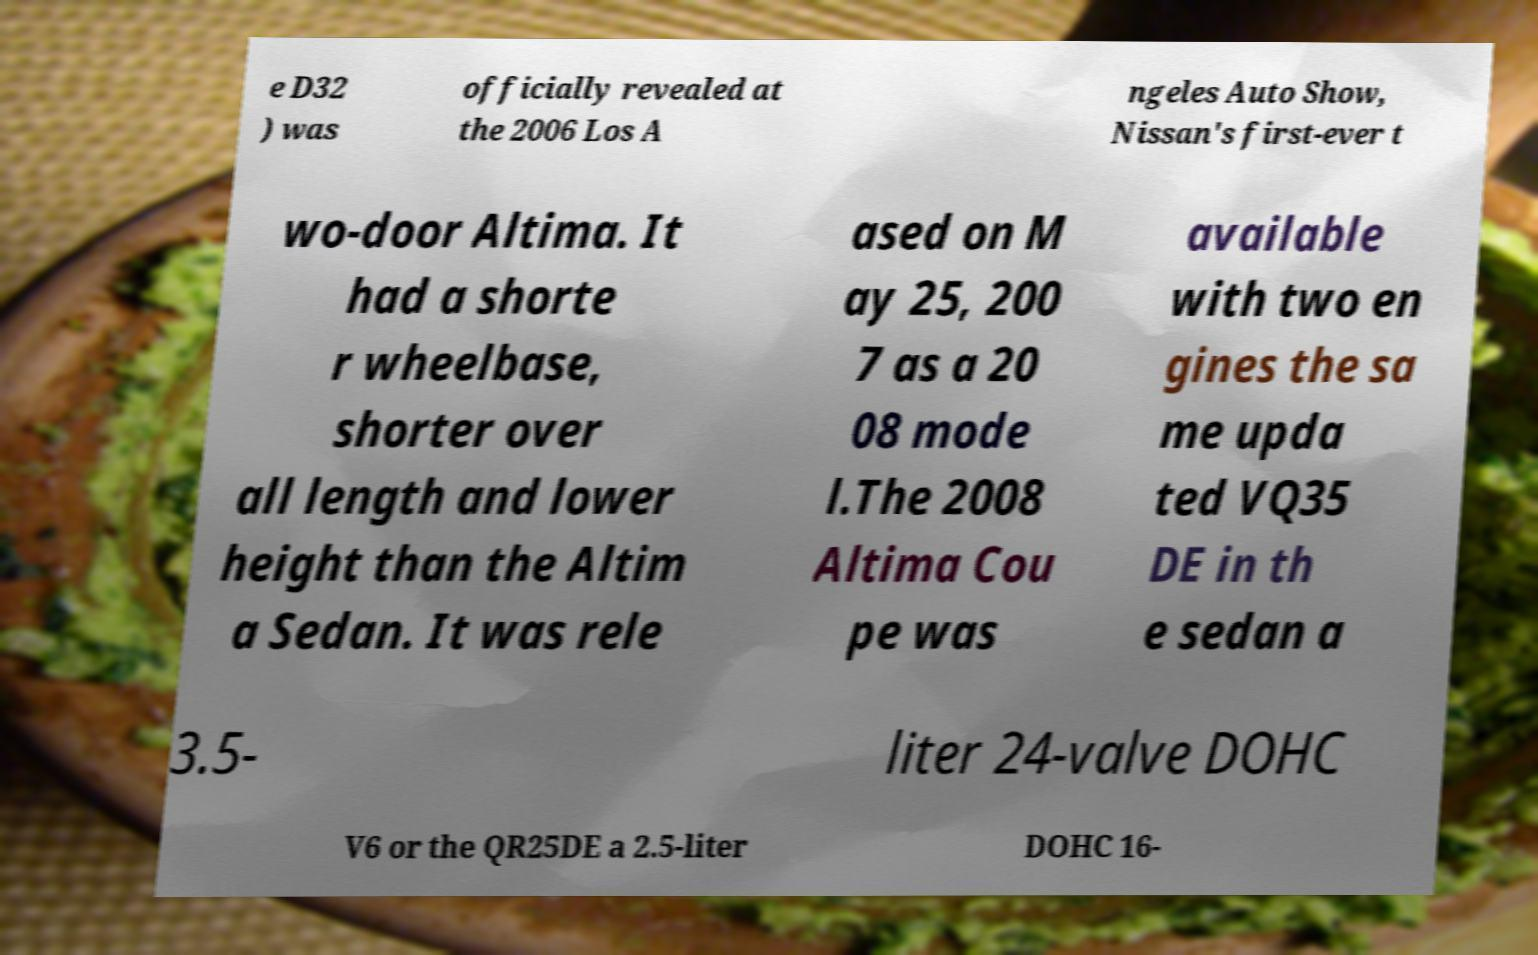Can you accurately transcribe the text from the provided image for me? e D32 ) was officially revealed at the 2006 Los A ngeles Auto Show, Nissan's first-ever t wo-door Altima. It had a shorte r wheelbase, shorter over all length and lower height than the Altim a Sedan. It was rele ased on M ay 25, 200 7 as a 20 08 mode l.The 2008 Altima Cou pe was available with two en gines the sa me upda ted VQ35 DE in th e sedan a 3.5- liter 24-valve DOHC V6 or the QR25DE a 2.5-liter DOHC 16- 